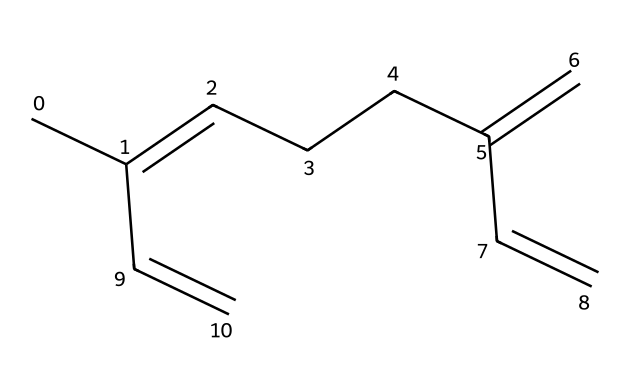What is the name of this compound? The SMILES representation indicates a structure commonly known as myrcene. It is a terpene found in bay laurel trees and is recognized for its distinct aromatic properties.
Answer: myrcene How many carbon atoms are present in myrcene? By analyzing the SMILES representation, we count a total of 10 carbon atoms present in the structure of myrcene. Each 'C' in the SMILES denotes a carbon atom, and the arrangement shows each is connected in a continuous chain with some double bonds.
Answer: 10 What type of bonds are present in myrcene? In myrcene, we observe both single and double bonds. The SMILES denotes that it has a mix of saturated (single) and unsaturated (double) connections between the carbon atoms, evidenced by the presence of multiple '=' signs.
Answer: single and double bonds Which functional group is characteristic of terpenes in myrcene? Terpenes like myrcene typically lack distinct functional groups such as alcohols or acids; however, they are primarily characterized by their hydrocarbon structure consisting of isoprene units. In myrcene, it demonstrates a hydrocarbon character without additional functional groups.
Answer: hydrocarbon How many double bonds does myrcene contain? Counting the '=' signs in the SMILES reveals that myrcene has three double bonds, showcasing its unsaturated nature. Each '=' indicates a double bond between carbons, contributing to the compound's reactivity and stability.
Answer: 3 What is the molecular formula of myrcene? From the total count of carbon and hydrogen in the structure, the molecular formula is derived from 10 carbon atoms and 16 hydrogen atoms, leading to the formula C10H16. This reflects the composition based on standard valency rules in organic chemistry.
Answer: C10H16 